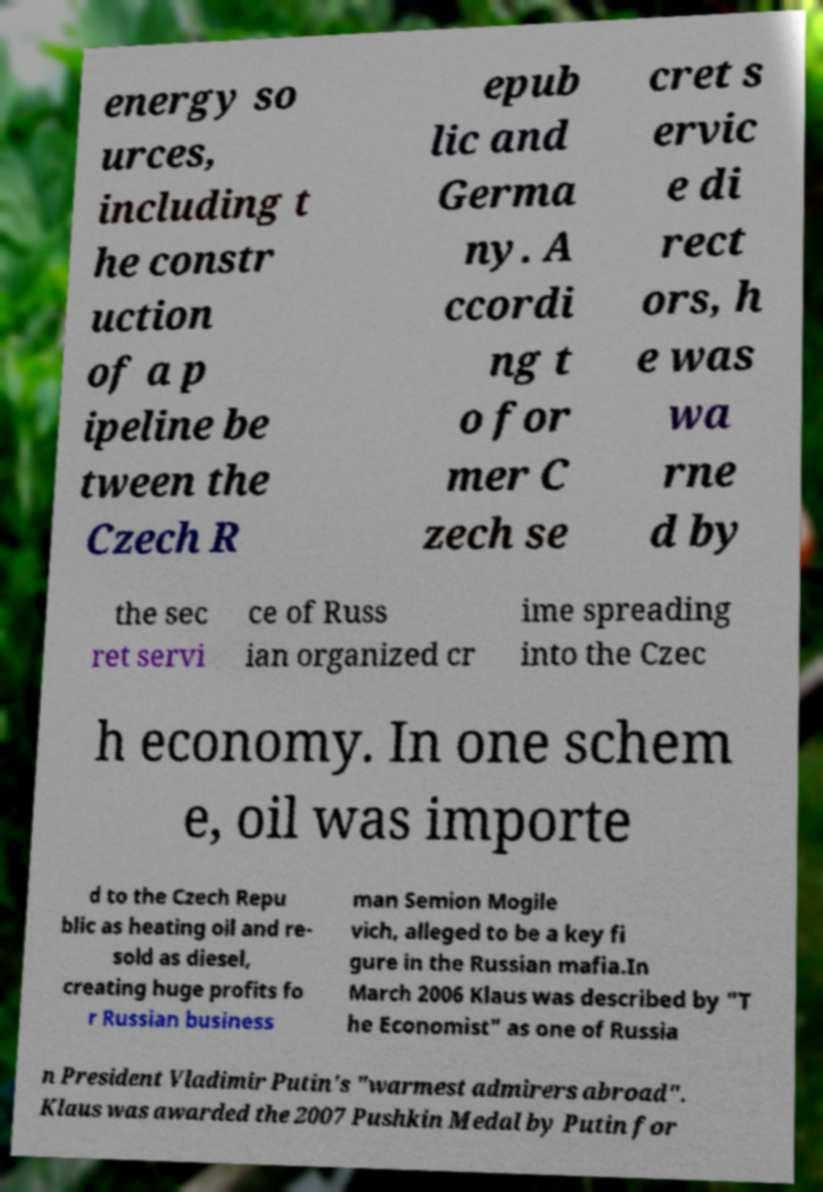Please identify and transcribe the text found in this image. energy so urces, including t he constr uction of a p ipeline be tween the Czech R epub lic and Germa ny. A ccordi ng t o for mer C zech se cret s ervic e di rect ors, h e was wa rne d by the sec ret servi ce of Russ ian organized cr ime spreading into the Czec h economy. In one schem e, oil was importe d to the Czech Repu blic as heating oil and re- sold as diesel, creating huge profits fo r Russian business man Semion Mogile vich, alleged to be a key fi gure in the Russian mafia.In March 2006 Klaus was described by "T he Economist" as one of Russia n President Vladimir Putin's "warmest admirers abroad". Klaus was awarded the 2007 Pushkin Medal by Putin for 